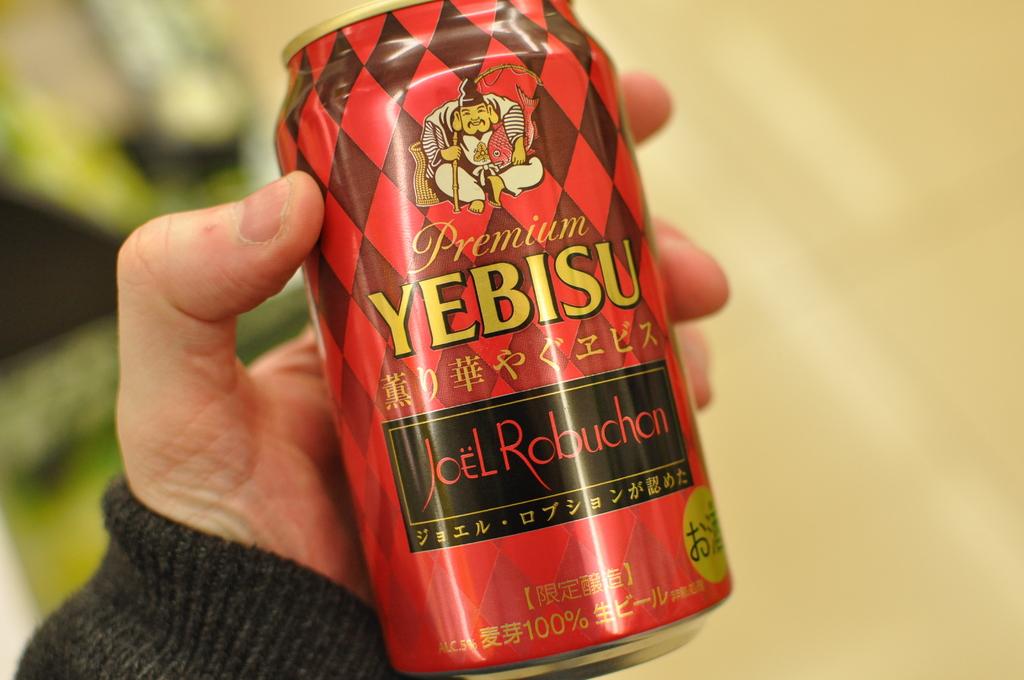What man's name is on this can?
Provide a succinct answer. Joel robuchan. 